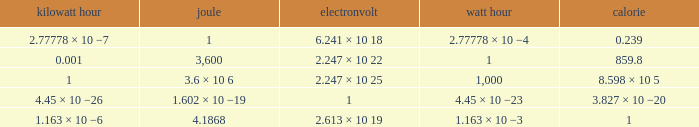How many electronvolts is 3,600 joules? 2.247 × 10 22. 